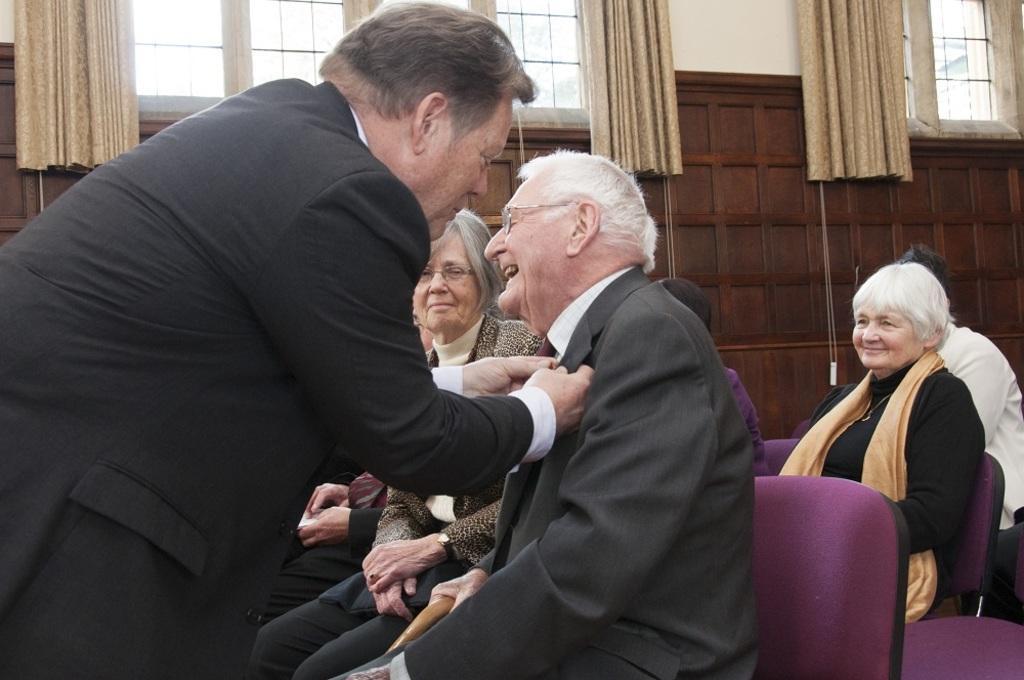Describe this image in one or two sentences. In this image we can see people sitting on chairs. To the left side of the image there is a person wearing a suit. In the background of the image there is wall. There are windows with curtains. 